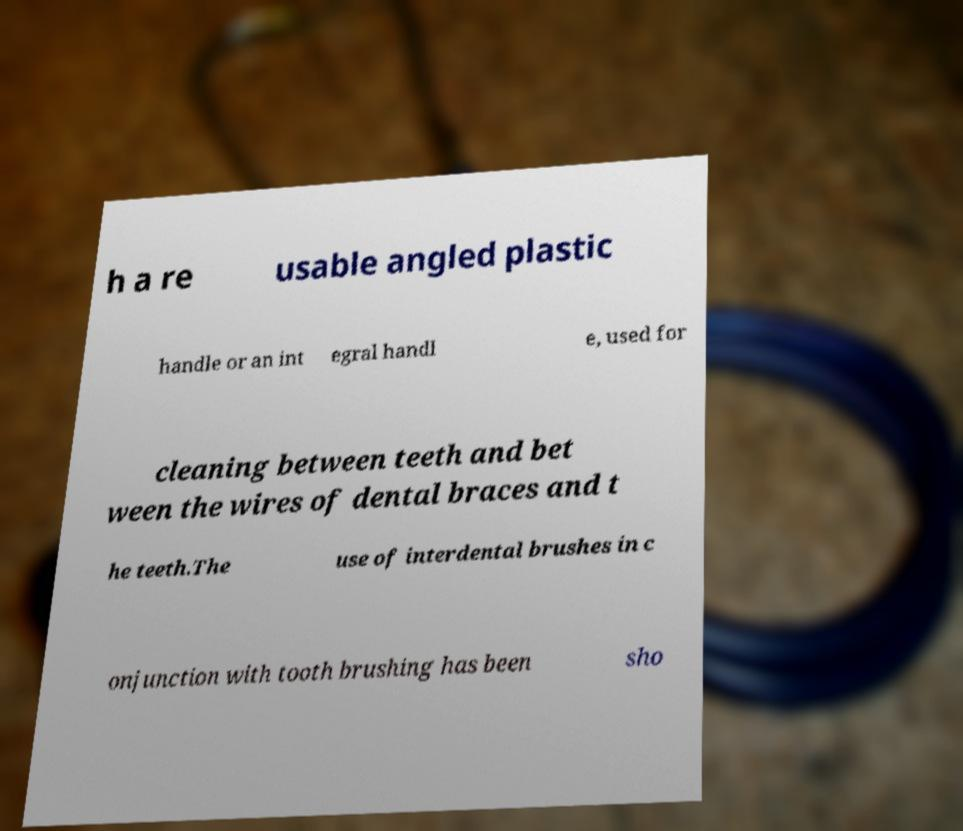Could you extract and type out the text from this image? h a re usable angled plastic handle or an int egral handl e, used for cleaning between teeth and bet ween the wires of dental braces and t he teeth.The use of interdental brushes in c onjunction with tooth brushing has been sho 